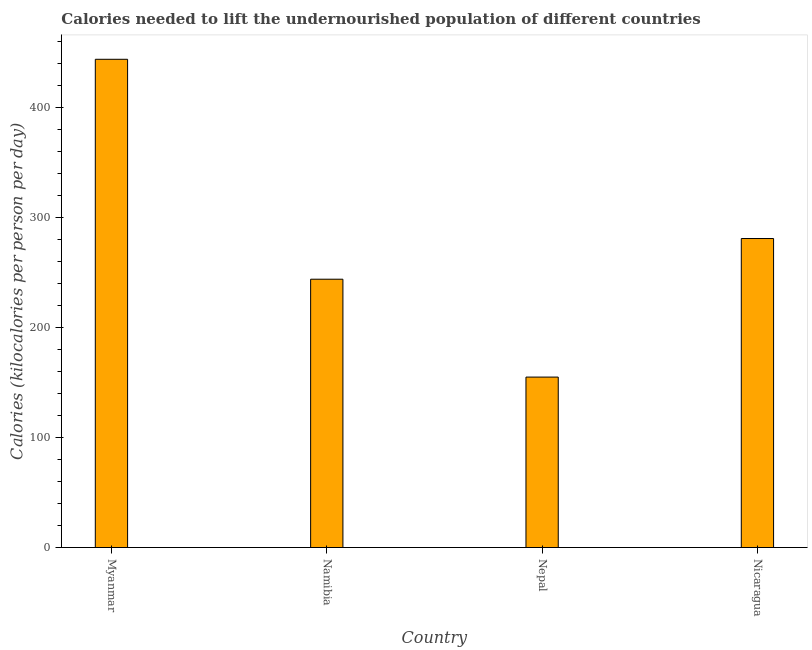Does the graph contain any zero values?
Offer a terse response. No. What is the title of the graph?
Your answer should be compact. Calories needed to lift the undernourished population of different countries. What is the label or title of the X-axis?
Keep it short and to the point. Country. What is the label or title of the Y-axis?
Provide a succinct answer. Calories (kilocalories per person per day). What is the depth of food deficit in Namibia?
Your response must be concise. 244. Across all countries, what is the maximum depth of food deficit?
Offer a terse response. 444. Across all countries, what is the minimum depth of food deficit?
Offer a very short reply. 155. In which country was the depth of food deficit maximum?
Your answer should be compact. Myanmar. In which country was the depth of food deficit minimum?
Your answer should be very brief. Nepal. What is the sum of the depth of food deficit?
Your answer should be very brief. 1124. What is the difference between the depth of food deficit in Nepal and Nicaragua?
Offer a very short reply. -126. What is the average depth of food deficit per country?
Make the answer very short. 281. What is the median depth of food deficit?
Keep it short and to the point. 262.5. What is the ratio of the depth of food deficit in Namibia to that in Nepal?
Ensure brevity in your answer.  1.57. What is the difference between the highest and the second highest depth of food deficit?
Your response must be concise. 163. What is the difference between the highest and the lowest depth of food deficit?
Your response must be concise. 289. How many bars are there?
Offer a terse response. 4. How many countries are there in the graph?
Ensure brevity in your answer.  4. What is the Calories (kilocalories per person per day) of Myanmar?
Give a very brief answer. 444. What is the Calories (kilocalories per person per day) of Namibia?
Offer a terse response. 244. What is the Calories (kilocalories per person per day) of Nepal?
Offer a terse response. 155. What is the Calories (kilocalories per person per day) in Nicaragua?
Offer a terse response. 281. What is the difference between the Calories (kilocalories per person per day) in Myanmar and Nepal?
Ensure brevity in your answer.  289. What is the difference between the Calories (kilocalories per person per day) in Myanmar and Nicaragua?
Keep it short and to the point. 163. What is the difference between the Calories (kilocalories per person per day) in Namibia and Nepal?
Offer a very short reply. 89. What is the difference between the Calories (kilocalories per person per day) in Namibia and Nicaragua?
Give a very brief answer. -37. What is the difference between the Calories (kilocalories per person per day) in Nepal and Nicaragua?
Your response must be concise. -126. What is the ratio of the Calories (kilocalories per person per day) in Myanmar to that in Namibia?
Offer a terse response. 1.82. What is the ratio of the Calories (kilocalories per person per day) in Myanmar to that in Nepal?
Make the answer very short. 2.87. What is the ratio of the Calories (kilocalories per person per day) in Myanmar to that in Nicaragua?
Provide a succinct answer. 1.58. What is the ratio of the Calories (kilocalories per person per day) in Namibia to that in Nepal?
Keep it short and to the point. 1.57. What is the ratio of the Calories (kilocalories per person per day) in Namibia to that in Nicaragua?
Your answer should be very brief. 0.87. What is the ratio of the Calories (kilocalories per person per day) in Nepal to that in Nicaragua?
Offer a very short reply. 0.55. 